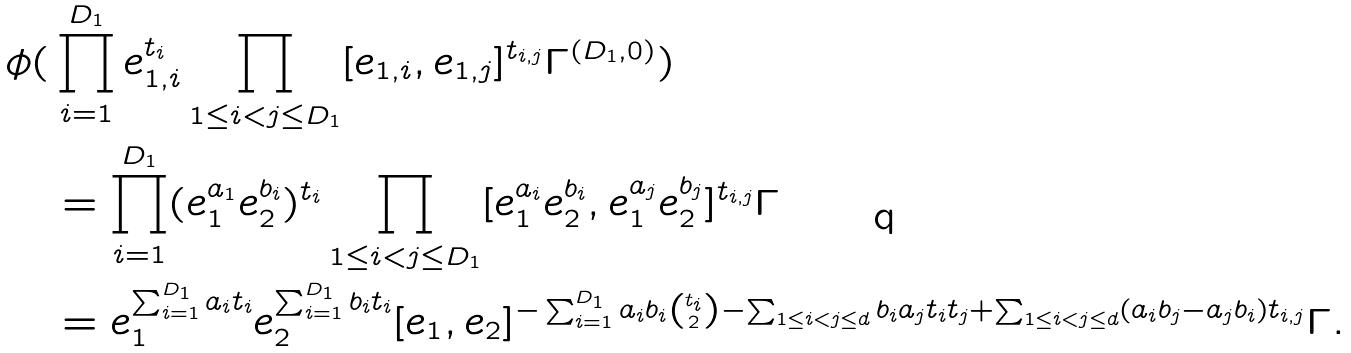<formula> <loc_0><loc_0><loc_500><loc_500>\phi ( & \prod _ { i = 1 } ^ { D _ { 1 } } e _ { 1 , i } ^ { t _ { i } } \prod _ { 1 \leq i < j \leq D _ { 1 } } [ e _ { 1 , i } , e _ { 1 , j } ] ^ { t _ { i , j } } \Gamma ^ { ( D _ { 1 } , 0 ) } ) \\ & = \prod _ { i = 1 } ^ { D _ { 1 } } ( e _ { 1 } ^ { a _ { 1 } } e _ { 2 } ^ { b _ { i } } ) ^ { t _ { i } } \prod _ { 1 \leq i < j \leq D _ { 1 } } [ e _ { 1 } ^ { a _ { i } } e _ { 2 } ^ { b _ { i } } , e _ { 1 } ^ { a _ { j } } e _ { 2 } ^ { b _ { j } } ] ^ { t _ { i , j } } \Gamma \\ & = e _ { 1 } ^ { \sum _ { i = 1 } ^ { D _ { 1 } } a _ { i } t _ { i } } e _ { 2 } ^ { \sum _ { i = 1 } ^ { D _ { 1 } } b _ { i } t _ { i } } [ e _ { 1 } , e _ { 2 } ] ^ { - \sum _ { i = 1 } ^ { D _ { 1 } } a _ { i } b _ { i } \binom { t _ { i } } { 2 } - \sum _ { 1 \leq i < j \leq d } b _ { i } a _ { j } t _ { i } t _ { j } + \sum _ { 1 \leq i < j \leq d } ( a _ { i } b _ { j } - a _ { j } b _ { i } ) t _ { i , j } } \Gamma .</formula> 